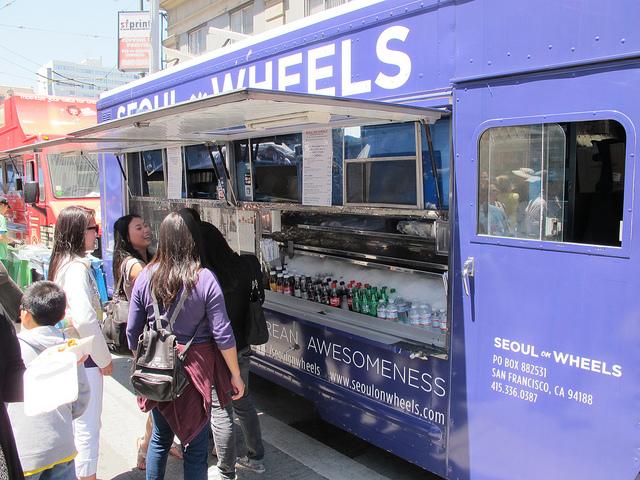Where are the sodas and waters?
Quick response, please. Food truck. Are people going to buy?
Quick response, please. Yes. How many billboards do you see?
Concise answer only. 1. What is the name of the food truck?
Write a very short answer. Seoul on wheels. 